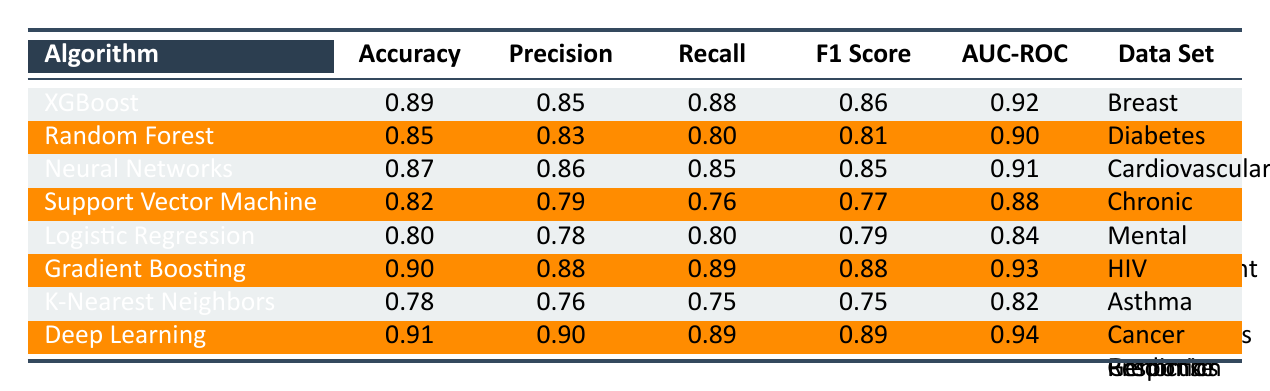What is the highest accuracy achieved by any algorithm in predicting personalized treatment outcomes? The algorithms listed show accuracy values ranging from 0.78 to 0.91. By inspecting the accuracy column, we find that the highest value is 0.91 achieved by the Deep Learning algorithm.
Answer: 0.91 Which algorithm has the lowest F1 Score? The F1 Scores from the table range from 0.75 to 0.89. Looking at the F1 Score column, K-Nearest Neighbors has the lowest value of 0.75.
Answer: 0.75 Which algorithm achieved the highest AUC-ROC value, and what is that value? The AUC-ROC values in the table range from 0.82 to 0.94. Upon reviewing the AUC-ROC column, the highest value is 0.94 achieved by the Deep Learning algorithm.
Answer: 0.94 Is the Precision of Neural Networks greater than that of Random Forest? The Precision values for Neural Networks and Random Forest are 0.86 and 0.83 respectively. Since 0.86 is greater than 0.83, the statement is true.
Answer: Yes What is the average Recall value for the algorithms listed in the table? To find the average Recall, we first sum all Recall values: 0.88 + 0.80 + 0.85 + 0.76 + 0.80 + 0.89 + 0.75 + 0.89 = 6.62. There are 8 algorithms, so we divide 6.62 by 8 to get the average Recall: 6.62 / 8 = 0.8275.
Answer: 0.83 Which data set does the algorithm XGBoost belong to? The table lists the data sets associated with each algorithm. For XGBoost, the associated data set is Breast Cancer Treatment Outcomes.
Answer: Breast Cancer Treatment Outcomes Which two algorithms have similar Precision values, but one has a significantly higher Accuracy? By examining the Accuracy and Precision values, XGBoost (Accuracy 0.89, Precision 0.85) and Neural Networks (Accuracy 0.87, Precision 0.86) have similar Precision values. However, XGBoost has a higher Accuracy compared to Neural Networks.
Answer: XGBoost and Neural Networks If the Precision for Support Vector Machine was improved by 0.05, what would be its new Precision? The current Precision for Support Vector Machine is 0.79. If it is improved by 0.05, we add: 0.79 + 0.05 = 0.84.
Answer: 0.84 Which algorithm has the greatest difference between its Recall and Precision values? We calculate the difference for each algorithm: XGBoost (0.88 - 0.85 = 0.03), Random Forest (0.80 - 0.83 = -0.03), Neural Networks (0.85 - 0.86 = -0.01), Support Vector Machine (0.76 - 0.79 = -0.03), Logistic Regression (0.80 - 0.78 = 0.02), Gradient Boosting (0.89 - 0.88 = 0.01), K-Nearest Neighbors (0.75 - 0.76 = -0.01), and Deep Learning (0.89 - 0.90 = -0.01). The maximum absolute difference is 0.03 for XGBoost, Random Forest, and Support Vector Machine.
Answer: XGBoost, Random Forest, and Support Vector Machine Which algorithm shows the best performance in terms of both Accuracy and AUC-ROC? By analyzing both the Accuracy and AUC-ROC columns, Deep Learning wins with the highest values, 0.91 for Accuracy and 0.94 for AUC-ROC.
Answer: Deep Learning 